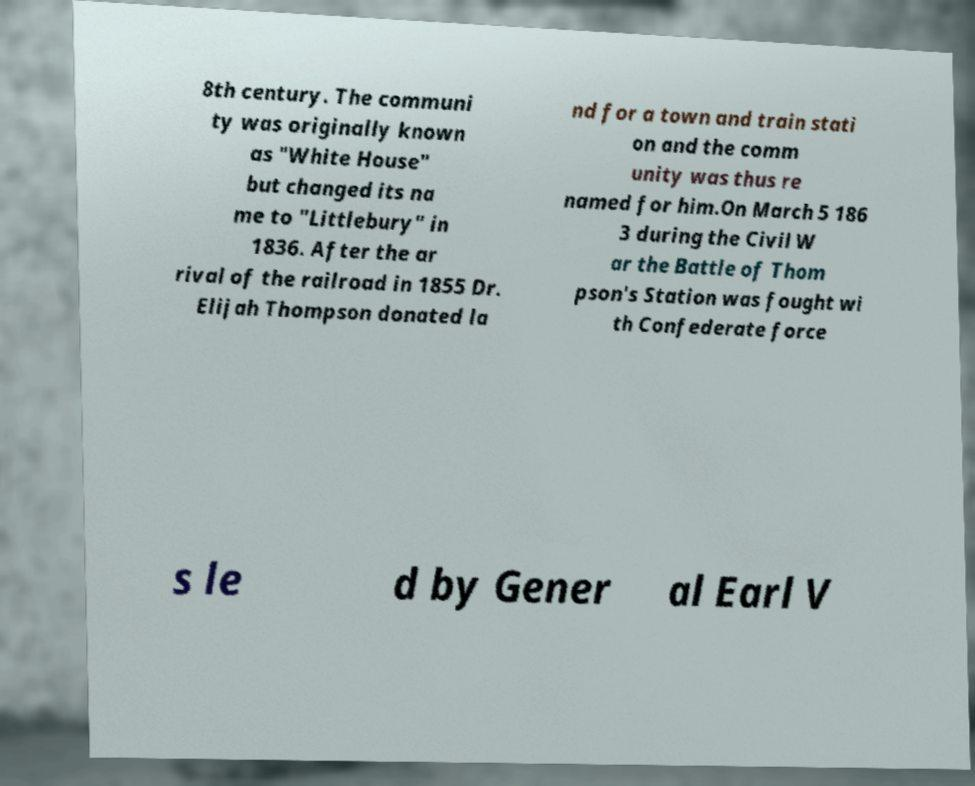For documentation purposes, I need the text within this image transcribed. Could you provide that? 8th century. The communi ty was originally known as "White House" but changed its na me to "Littlebury" in 1836. After the ar rival of the railroad in 1855 Dr. Elijah Thompson donated la nd for a town and train stati on and the comm unity was thus re named for him.On March 5 186 3 during the Civil W ar the Battle of Thom pson's Station was fought wi th Confederate force s le d by Gener al Earl V 